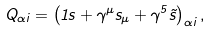Convert formula to latex. <formula><loc_0><loc_0><loc_500><loc_500>Q _ { \alpha i } = \left ( 1 s + \gamma ^ { \mu } s _ { \mu } + \gamma ^ { 5 } \tilde { s } \right ) _ { \alpha i } ,</formula> 